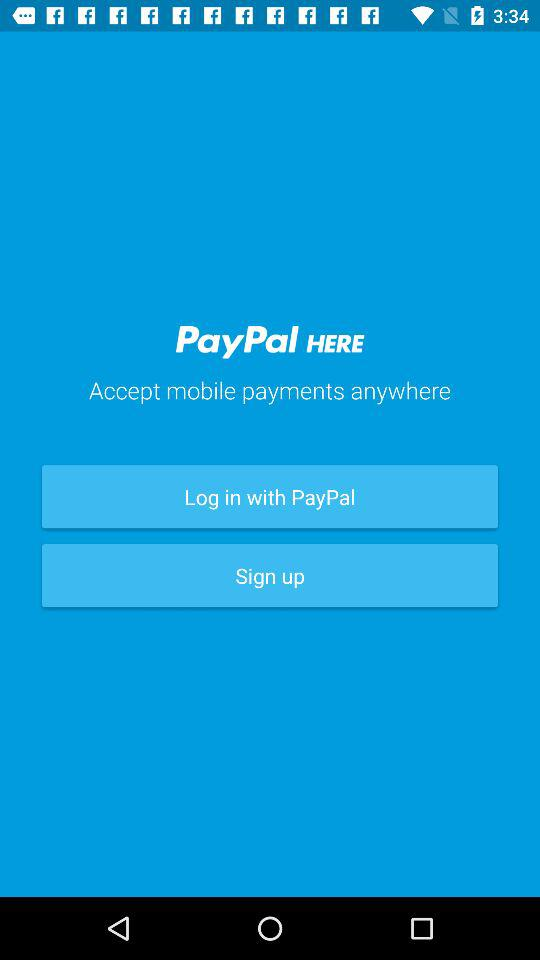Who is logging in or signing up?
When the provided information is insufficient, respond with <no answer>. <no answer> 